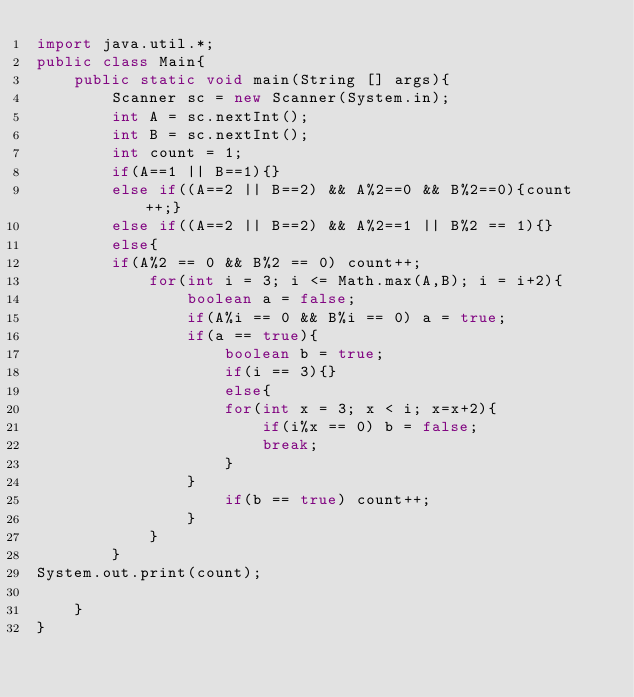<code> <loc_0><loc_0><loc_500><loc_500><_Java_>import java.util.*;
public class Main{
    public static void main(String [] args){
        Scanner sc = new Scanner(System.in);
        int A = sc.nextInt();
        int B = sc.nextInt();
        int count = 1;
        if(A==1 || B==1){}
        else if((A==2 || B==2) && A%2==0 && B%2==0){count++;}
        else if((A==2 || B==2) && A%2==1 || B%2 == 1){}
        else{
        if(A%2 == 0 && B%2 == 0) count++;
            for(int i = 3; i <= Math.max(A,B); i = i+2){
                boolean a = false;
                if(A%i == 0 && B%i == 0) a = true;
                if(a == true){
                    boolean b = true;
                    if(i == 3){}
                    else{
                    for(int x = 3; x < i; x=x+2){
                        if(i%x == 0) b = false;
                        break;
                    }
                }
                    if(b == true) count++;
                } 
            }
        }
System.out.print(count);

    }
}

</code> 